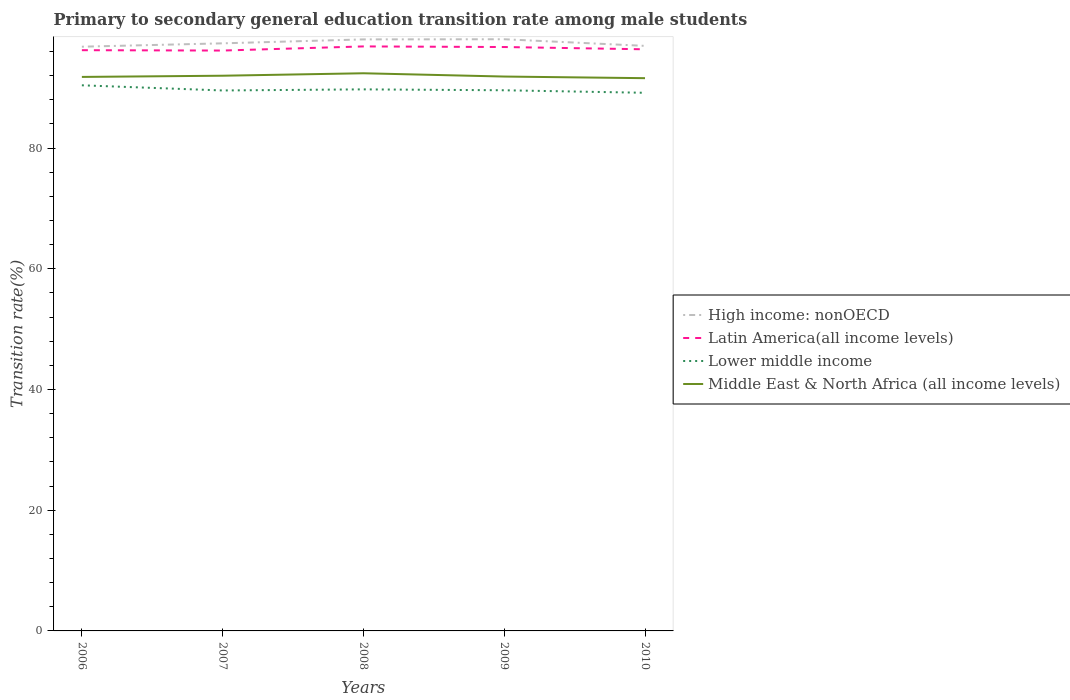Does the line corresponding to Lower middle income intersect with the line corresponding to High income: nonOECD?
Provide a succinct answer. No. Across all years, what is the maximum transition rate in Lower middle income?
Offer a terse response. 89.15. What is the total transition rate in Lower middle income in the graph?
Make the answer very short. 0.57. What is the difference between the highest and the second highest transition rate in High income: nonOECD?
Offer a very short reply. 1.23. What is the difference between the highest and the lowest transition rate in Middle East & North Africa (all income levels)?
Offer a terse response. 2. How many years are there in the graph?
Ensure brevity in your answer.  5. What is the difference between two consecutive major ticks on the Y-axis?
Make the answer very short. 20. Does the graph contain any zero values?
Offer a very short reply. No. Does the graph contain grids?
Offer a terse response. No. How many legend labels are there?
Your response must be concise. 4. What is the title of the graph?
Your answer should be very brief. Primary to secondary general education transition rate among male students. What is the label or title of the X-axis?
Ensure brevity in your answer.  Years. What is the label or title of the Y-axis?
Make the answer very short. Transition rate(%). What is the Transition rate(%) in High income: nonOECD in 2006?
Provide a short and direct response. 96.79. What is the Transition rate(%) in Latin America(all income levels) in 2006?
Provide a short and direct response. 96.21. What is the Transition rate(%) in Lower middle income in 2006?
Your answer should be very brief. 90.39. What is the Transition rate(%) of Middle East & North Africa (all income levels) in 2006?
Keep it short and to the point. 91.78. What is the Transition rate(%) of High income: nonOECD in 2007?
Offer a terse response. 97.34. What is the Transition rate(%) of Latin America(all income levels) in 2007?
Offer a very short reply. 96.15. What is the Transition rate(%) of Lower middle income in 2007?
Your answer should be compact. 89.54. What is the Transition rate(%) of Middle East & North Africa (all income levels) in 2007?
Your response must be concise. 91.98. What is the Transition rate(%) in High income: nonOECD in 2008?
Offer a very short reply. 98. What is the Transition rate(%) of Latin America(all income levels) in 2008?
Make the answer very short. 96.83. What is the Transition rate(%) of Lower middle income in 2008?
Ensure brevity in your answer.  89.72. What is the Transition rate(%) of Middle East & North Africa (all income levels) in 2008?
Make the answer very short. 92.38. What is the Transition rate(%) in High income: nonOECD in 2009?
Ensure brevity in your answer.  98.02. What is the Transition rate(%) of Latin America(all income levels) in 2009?
Offer a very short reply. 96.73. What is the Transition rate(%) in Lower middle income in 2009?
Offer a very short reply. 89.57. What is the Transition rate(%) of Middle East & North Africa (all income levels) in 2009?
Ensure brevity in your answer.  91.84. What is the Transition rate(%) of High income: nonOECD in 2010?
Give a very brief answer. 96.92. What is the Transition rate(%) in Latin America(all income levels) in 2010?
Your response must be concise. 96.36. What is the Transition rate(%) of Lower middle income in 2010?
Provide a succinct answer. 89.15. What is the Transition rate(%) in Middle East & North Africa (all income levels) in 2010?
Offer a terse response. 91.57. Across all years, what is the maximum Transition rate(%) of High income: nonOECD?
Your answer should be compact. 98.02. Across all years, what is the maximum Transition rate(%) in Latin America(all income levels)?
Your answer should be very brief. 96.83. Across all years, what is the maximum Transition rate(%) in Lower middle income?
Provide a short and direct response. 90.39. Across all years, what is the maximum Transition rate(%) in Middle East & North Africa (all income levels)?
Provide a succinct answer. 92.38. Across all years, what is the minimum Transition rate(%) in High income: nonOECD?
Keep it short and to the point. 96.79. Across all years, what is the minimum Transition rate(%) in Latin America(all income levels)?
Your answer should be very brief. 96.15. Across all years, what is the minimum Transition rate(%) in Lower middle income?
Keep it short and to the point. 89.15. Across all years, what is the minimum Transition rate(%) of Middle East & North Africa (all income levels)?
Give a very brief answer. 91.57. What is the total Transition rate(%) of High income: nonOECD in the graph?
Ensure brevity in your answer.  487.07. What is the total Transition rate(%) of Latin America(all income levels) in the graph?
Provide a succinct answer. 482.28. What is the total Transition rate(%) of Lower middle income in the graph?
Your answer should be very brief. 448.36. What is the total Transition rate(%) of Middle East & North Africa (all income levels) in the graph?
Provide a succinct answer. 459.56. What is the difference between the Transition rate(%) in High income: nonOECD in 2006 and that in 2007?
Give a very brief answer. -0.56. What is the difference between the Transition rate(%) of Latin America(all income levels) in 2006 and that in 2007?
Provide a short and direct response. 0.06. What is the difference between the Transition rate(%) of Lower middle income in 2006 and that in 2007?
Offer a terse response. 0.86. What is the difference between the Transition rate(%) of Middle East & North Africa (all income levels) in 2006 and that in 2007?
Provide a succinct answer. -0.2. What is the difference between the Transition rate(%) of High income: nonOECD in 2006 and that in 2008?
Your answer should be compact. -1.21. What is the difference between the Transition rate(%) in Latin America(all income levels) in 2006 and that in 2008?
Keep it short and to the point. -0.63. What is the difference between the Transition rate(%) of Lower middle income in 2006 and that in 2008?
Keep it short and to the point. 0.67. What is the difference between the Transition rate(%) of Middle East & North Africa (all income levels) in 2006 and that in 2008?
Your response must be concise. -0.6. What is the difference between the Transition rate(%) of High income: nonOECD in 2006 and that in 2009?
Offer a terse response. -1.23. What is the difference between the Transition rate(%) in Latin America(all income levels) in 2006 and that in 2009?
Your answer should be compact. -0.52. What is the difference between the Transition rate(%) of Lower middle income in 2006 and that in 2009?
Keep it short and to the point. 0.82. What is the difference between the Transition rate(%) of Middle East & North Africa (all income levels) in 2006 and that in 2009?
Offer a terse response. -0.06. What is the difference between the Transition rate(%) of High income: nonOECD in 2006 and that in 2010?
Make the answer very short. -0.14. What is the difference between the Transition rate(%) of Latin America(all income levels) in 2006 and that in 2010?
Your answer should be compact. -0.15. What is the difference between the Transition rate(%) of Lower middle income in 2006 and that in 2010?
Your response must be concise. 1.24. What is the difference between the Transition rate(%) in Middle East & North Africa (all income levels) in 2006 and that in 2010?
Offer a terse response. 0.21. What is the difference between the Transition rate(%) of High income: nonOECD in 2007 and that in 2008?
Offer a terse response. -0.65. What is the difference between the Transition rate(%) of Latin America(all income levels) in 2007 and that in 2008?
Give a very brief answer. -0.69. What is the difference between the Transition rate(%) in Lower middle income in 2007 and that in 2008?
Ensure brevity in your answer.  -0.18. What is the difference between the Transition rate(%) in Middle East & North Africa (all income levels) in 2007 and that in 2008?
Provide a succinct answer. -0.4. What is the difference between the Transition rate(%) in High income: nonOECD in 2007 and that in 2009?
Your answer should be very brief. -0.68. What is the difference between the Transition rate(%) in Latin America(all income levels) in 2007 and that in 2009?
Provide a short and direct response. -0.58. What is the difference between the Transition rate(%) in Lower middle income in 2007 and that in 2009?
Ensure brevity in your answer.  -0.03. What is the difference between the Transition rate(%) of Middle East & North Africa (all income levels) in 2007 and that in 2009?
Give a very brief answer. 0.14. What is the difference between the Transition rate(%) in High income: nonOECD in 2007 and that in 2010?
Give a very brief answer. 0.42. What is the difference between the Transition rate(%) of Latin America(all income levels) in 2007 and that in 2010?
Keep it short and to the point. -0.21. What is the difference between the Transition rate(%) in Lower middle income in 2007 and that in 2010?
Keep it short and to the point. 0.38. What is the difference between the Transition rate(%) of Middle East & North Africa (all income levels) in 2007 and that in 2010?
Give a very brief answer. 0.41. What is the difference between the Transition rate(%) in High income: nonOECD in 2008 and that in 2009?
Give a very brief answer. -0.02. What is the difference between the Transition rate(%) in Latin America(all income levels) in 2008 and that in 2009?
Provide a succinct answer. 0.1. What is the difference between the Transition rate(%) in Lower middle income in 2008 and that in 2009?
Your response must be concise. 0.15. What is the difference between the Transition rate(%) of Middle East & North Africa (all income levels) in 2008 and that in 2009?
Make the answer very short. 0.54. What is the difference between the Transition rate(%) in High income: nonOECD in 2008 and that in 2010?
Offer a terse response. 1.07. What is the difference between the Transition rate(%) in Latin America(all income levels) in 2008 and that in 2010?
Your response must be concise. 0.48. What is the difference between the Transition rate(%) in Lower middle income in 2008 and that in 2010?
Your answer should be compact. 0.57. What is the difference between the Transition rate(%) in Middle East & North Africa (all income levels) in 2008 and that in 2010?
Make the answer very short. 0.81. What is the difference between the Transition rate(%) of High income: nonOECD in 2009 and that in 2010?
Your answer should be compact. 1.1. What is the difference between the Transition rate(%) in Latin America(all income levels) in 2009 and that in 2010?
Offer a very short reply. 0.38. What is the difference between the Transition rate(%) in Lower middle income in 2009 and that in 2010?
Ensure brevity in your answer.  0.42. What is the difference between the Transition rate(%) of Middle East & North Africa (all income levels) in 2009 and that in 2010?
Provide a succinct answer. 0.27. What is the difference between the Transition rate(%) in High income: nonOECD in 2006 and the Transition rate(%) in Latin America(all income levels) in 2007?
Provide a succinct answer. 0.64. What is the difference between the Transition rate(%) of High income: nonOECD in 2006 and the Transition rate(%) of Lower middle income in 2007?
Provide a succinct answer. 7.25. What is the difference between the Transition rate(%) of High income: nonOECD in 2006 and the Transition rate(%) of Middle East & North Africa (all income levels) in 2007?
Offer a terse response. 4.81. What is the difference between the Transition rate(%) of Latin America(all income levels) in 2006 and the Transition rate(%) of Lower middle income in 2007?
Provide a short and direct response. 6.67. What is the difference between the Transition rate(%) of Latin America(all income levels) in 2006 and the Transition rate(%) of Middle East & North Africa (all income levels) in 2007?
Your answer should be compact. 4.23. What is the difference between the Transition rate(%) of Lower middle income in 2006 and the Transition rate(%) of Middle East & North Africa (all income levels) in 2007?
Offer a terse response. -1.59. What is the difference between the Transition rate(%) of High income: nonOECD in 2006 and the Transition rate(%) of Latin America(all income levels) in 2008?
Offer a terse response. -0.05. What is the difference between the Transition rate(%) in High income: nonOECD in 2006 and the Transition rate(%) in Lower middle income in 2008?
Provide a short and direct response. 7.07. What is the difference between the Transition rate(%) in High income: nonOECD in 2006 and the Transition rate(%) in Middle East & North Africa (all income levels) in 2008?
Provide a succinct answer. 4.4. What is the difference between the Transition rate(%) in Latin America(all income levels) in 2006 and the Transition rate(%) in Lower middle income in 2008?
Offer a terse response. 6.49. What is the difference between the Transition rate(%) of Latin America(all income levels) in 2006 and the Transition rate(%) of Middle East & North Africa (all income levels) in 2008?
Keep it short and to the point. 3.82. What is the difference between the Transition rate(%) of Lower middle income in 2006 and the Transition rate(%) of Middle East & North Africa (all income levels) in 2008?
Give a very brief answer. -1.99. What is the difference between the Transition rate(%) of High income: nonOECD in 2006 and the Transition rate(%) of Latin America(all income levels) in 2009?
Provide a succinct answer. 0.05. What is the difference between the Transition rate(%) of High income: nonOECD in 2006 and the Transition rate(%) of Lower middle income in 2009?
Your answer should be compact. 7.22. What is the difference between the Transition rate(%) in High income: nonOECD in 2006 and the Transition rate(%) in Middle East & North Africa (all income levels) in 2009?
Provide a succinct answer. 4.94. What is the difference between the Transition rate(%) of Latin America(all income levels) in 2006 and the Transition rate(%) of Lower middle income in 2009?
Keep it short and to the point. 6.64. What is the difference between the Transition rate(%) of Latin America(all income levels) in 2006 and the Transition rate(%) of Middle East & North Africa (all income levels) in 2009?
Make the answer very short. 4.37. What is the difference between the Transition rate(%) of Lower middle income in 2006 and the Transition rate(%) of Middle East & North Africa (all income levels) in 2009?
Give a very brief answer. -1.45. What is the difference between the Transition rate(%) in High income: nonOECD in 2006 and the Transition rate(%) in Latin America(all income levels) in 2010?
Make the answer very short. 0.43. What is the difference between the Transition rate(%) of High income: nonOECD in 2006 and the Transition rate(%) of Lower middle income in 2010?
Offer a terse response. 7.63. What is the difference between the Transition rate(%) of High income: nonOECD in 2006 and the Transition rate(%) of Middle East & North Africa (all income levels) in 2010?
Provide a succinct answer. 5.21. What is the difference between the Transition rate(%) in Latin America(all income levels) in 2006 and the Transition rate(%) in Lower middle income in 2010?
Keep it short and to the point. 7.06. What is the difference between the Transition rate(%) of Latin America(all income levels) in 2006 and the Transition rate(%) of Middle East & North Africa (all income levels) in 2010?
Offer a terse response. 4.63. What is the difference between the Transition rate(%) in Lower middle income in 2006 and the Transition rate(%) in Middle East & North Africa (all income levels) in 2010?
Keep it short and to the point. -1.18. What is the difference between the Transition rate(%) in High income: nonOECD in 2007 and the Transition rate(%) in Latin America(all income levels) in 2008?
Give a very brief answer. 0.51. What is the difference between the Transition rate(%) of High income: nonOECD in 2007 and the Transition rate(%) of Lower middle income in 2008?
Your answer should be compact. 7.63. What is the difference between the Transition rate(%) of High income: nonOECD in 2007 and the Transition rate(%) of Middle East & North Africa (all income levels) in 2008?
Provide a succinct answer. 4.96. What is the difference between the Transition rate(%) of Latin America(all income levels) in 2007 and the Transition rate(%) of Lower middle income in 2008?
Keep it short and to the point. 6.43. What is the difference between the Transition rate(%) of Latin America(all income levels) in 2007 and the Transition rate(%) of Middle East & North Africa (all income levels) in 2008?
Keep it short and to the point. 3.76. What is the difference between the Transition rate(%) of Lower middle income in 2007 and the Transition rate(%) of Middle East & North Africa (all income levels) in 2008?
Provide a succinct answer. -2.85. What is the difference between the Transition rate(%) in High income: nonOECD in 2007 and the Transition rate(%) in Latin America(all income levels) in 2009?
Your answer should be compact. 0.61. What is the difference between the Transition rate(%) in High income: nonOECD in 2007 and the Transition rate(%) in Lower middle income in 2009?
Offer a very short reply. 7.78. What is the difference between the Transition rate(%) in High income: nonOECD in 2007 and the Transition rate(%) in Middle East & North Africa (all income levels) in 2009?
Make the answer very short. 5.5. What is the difference between the Transition rate(%) of Latin America(all income levels) in 2007 and the Transition rate(%) of Lower middle income in 2009?
Provide a succinct answer. 6.58. What is the difference between the Transition rate(%) of Latin America(all income levels) in 2007 and the Transition rate(%) of Middle East & North Africa (all income levels) in 2009?
Provide a succinct answer. 4.31. What is the difference between the Transition rate(%) in Lower middle income in 2007 and the Transition rate(%) in Middle East & North Africa (all income levels) in 2009?
Provide a short and direct response. -2.31. What is the difference between the Transition rate(%) of High income: nonOECD in 2007 and the Transition rate(%) of Lower middle income in 2010?
Your answer should be compact. 8.19. What is the difference between the Transition rate(%) in High income: nonOECD in 2007 and the Transition rate(%) in Middle East & North Africa (all income levels) in 2010?
Your response must be concise. 5.77. What is the difference between the Transition rate(%) in Latin America(all income levels) in 2007 and the Transition rate(%) in Lower middle income in 2010?
Ensure brevity in your answer.  7. What is the difference between the Transition rate(%) in Latin America(all income levels) in 2007 and the Transition rate(%) in Middle East & North Africa (all income levels) in 2010?
Ensure brevity in your answer.  4.57. What is the difference between the Transition rate(%) of Lower middle income in 2007 and the Transition rate(%) of Middle East & North Africa (all income levels) in 2010?
Offer a very short reply. -2.04. What is the difference between the Transition rate(%) of High income: nonOECD in 2008 and the Transition rate(%) of Latin America(all income levels) in 2009?
Provide a short and direct response. 1.26. What is the difference between the Transition rate(%) of High income: nonOECD in 2008 and the Transition rate(%) of Lower middle income in 2009?
Provide a succinct answer. 8.43. What is the difference between the Transition rate(%) in High income: nonOECD in 2008 and the Transition rate(%) in Middle East & North Africa (all income levels) in 2009?
Give a very brief answer. 6.15. What is the difference between the Transition rate(%) in Latin America(all income levels) in 2008 and the Transition rate(%) in Lower middle income in 2009?
Your answer should be compact. 7.26. What is the difference between the Transition rate(%) of Latin America(all income levels) in 2008 and the Transition rate(%) of Middle East & North Africa (all income levels) in 2009?
Your response must be concise. 4.99. What is the difference between the Transition rate(%) of Lower middle income in 2008 and the Transition rate(%) of Middle East & North Africa (all income levels) in 2009?
Your response must be concise. -2.13. What is the difference between the Transition rate(%) in High income: nonOECD in 2008 and the Transition rate(%) in Latin America(all income levels) in 2010?
Your response must be concise. 1.64. What is the difference between the Transition rate(%) in High income: nonOECD in 2008 and the Transition rate(%) in Lower middle income in 2010?
Ensure brevity in your answer.  8.84. What is the difference between the Transition rate(%) of High income: nonOECD in 2008 and the Transition rate(%) of Middle East & North Africa (all income levels) in 2010?
Ensure brevity in your answer.  6.42. What is the difference between the Transition rate(%) of Latin America(all income levels) in 2008 and the Transition rate(%) of Lower middle income in 2010?
Your answer should be very brief. 7.68. What is the difference between the Transition rate(%) of Latin America(all income levels) in 2008 and the Transition rate(%) of Middle East & North Africa (all income levels) in 2010?
Ensure brevity in your answer.  5.26. What is the difference between the Transition rate(%) in Lower middle income in 2008 and the Transition rate(%) in Middle East & North Africa (all income levels) in 2010?
Provide a succinct answer. -1.86. What is the difference between the Transition rate(%) of High income: nonOECD in 2009 and the Transition rate(%) of Latin America(all income levels) in 2010?
Offer a very short reply. 1.66. What is the difference between the Transition rate(%) in High income: nonOECD in 2009 and the Transition rate(%) in Lower middle income in 2010?
Provide a succinct answer. 8.87. What is the difference between the Transition rate(%) in High income: nonOECD in 2009 and the Transition rate(%) in Middle East & North Africa (all income levels) in 2010?
Offer a very short reply. 6.45. What is the difference between the Transition rate(%) of Latin America(all income levels) in 2009 and the Transition rate(%) of Lower middle income in 2010?
Provide a short and direct response. 7.58. What is the difference between the Transition rate(%) of Latin America(all income levels) in 2009 and the Transition rate(%) of Middle East & North Africa (all income levels) in 2010?
Offer a very short reply. 5.16. What is the difference between the Transition rate(%) of Lower middle income in 2009 and the Transition rate(%) of Middle East & North Africa (all income levels) in 2010?
Your answer should be very brief. -2. What is the average Transition rate(%) of High income: nonOECD per year?
Your answer should be compact. 97.41. What is the average Transition rate(%) in Latin America(all income levels) per year?
Ensure brevity in your answer.  96.46. What is the average Transition rate(%) in Lower middle income per year?
Make the answer very short. 89.67. What is the average Transition rate(%) of Middle East & North Africa (all income levels) per year?
Provide a short and direct response. 91.91. In the year 2006, what is the difference between the Transition rate(%) in High income: nonOECD and Transition rate(%) in Latin America(all income levels)?
Offer a very short reply. 0.58. In the year 2006, what is the difference between the Transition rate(%) in High income: nonOECD and Transition rate(%) in Lower middle income?
Your answer should be compact. 6.4. In the year 2006, what is the difference between the Transition rate(%) in High income: nonOECD and Transition rate(%) in Middle East & North Africa (all income levels)?
Provide a succinct answer. 5.01. In the year 2006, what is the difference between the Transition rate(%) of Latin America(all income levels) and Transition rate(%) of Lower middle income?
Your answer should be compact. 5.82. In the year 2006, what is the difference between the Transition rate(%) of Latin America(all income levels) and Transition rate(%) of Middle East & North Africa (all income levels)?
Keep it short and to the point. 4.43. In the year 2006, what is the difference between the Transition rate(%) in Lower middle income and Transition rate(%) in Middle East & North Africa (all income levels)?
Your answer should be compact. -1.39. In the year 2007, what is the difference between the Transition rate(%) in High income: nonOECD and Transition rate(%) in Latin America(all income levels)?
Keep it short and to the point. 1.2. In the year 2007, what is the difference between the Transition rate(%) of High income: nonOECD and Transition rate(%) of Lower middle income?
Your answer should be very brief. 7.81. In the year 2007, what is the difference between the Transition rate(%) of High income: nonOECD and Transition rate(%) of Middle East & North Africa (all income levels)?
Offer a terse response. 5.36. In the year 2007, what is the difference between the Transition rate(%) in Latin America(all income levels) and Transition rate(%) in Lower middle income?
Make the answer very short. 6.61. In the year 2007, what is the difference between the Transition rate(%) in Latin America(all income levels) and Transition rate(%) in Middle East & North Africa (all income levels)?
Offer a terse response. 4.17. In the year 2007, what is the difference between the Transition rate(%) of Lower middle income and Transition rate(%) of Middle East & North Africa (all income levels)?
Your response must be concise. -2.44. In the year 2008, what is the difference between the Transition rate(%) in High income: nonOECD and Transition rate(%) in Latin America(all income levels)?
Ensure brevity in your answer.  1.16. In the year 2008, what is the difference between the Transition rate(%) of High income: nonOECD and Transition rate(%) of Lower middle income?
Give a very brief answer. 8.28. In the year 2008, what is the difference between the Transition rate(%) of High income: nonOECD and Transition rate(%) of Middle East & North Africa (all income levels)?
Provide a succinct answer. 5.61. In the year 2008, what is the difference between the Transition rate(%) in Latin America(all income levels) and Transition rate(%) in Lower middle income?
Make the answer very short. 7.12. In the year 2008, what is the difference between the Transition rate(%) in Latin America(all income levels) and Transition rate(%) in Middle East & North Africa (all income levels)?
Your response must be concise. 4.45. In the year 2008, what is the difference between the Transition rate(%) in Lower middle income and Transition rate(%) in Middle East & North Africa (all income levels)?
Offer a terse response. -2.67. In the year 2009, what is the difference between the Transition rate(%) in High income: nonOECD and Transition rate(%) in Latin America(all income levels)?
Offer a very short reply. 1.29. In the year 2009, what is the difference between the Transition rate(%) in High income: nonOECD and Transition rate(%) in Lower middle income?
Keep it short and to the point. 8.45. In the year 2009, what is the difference between the Transition rate(%) in High income: nonOECD and Transition rate(%) in Middle East & North Africa (all income levels)?
Provide a succinct answer. 6.18. In the year 2009, what is the difference between the Transition rate(%) in Latin America(all income levels) and Transition rate(%) in Lower middle income?
Give a very brief answer. 7.16. In the year 2009, what is the difference between the Transition rate(%) of Latin America(all income levels) and Transition rate(%) of Middle East & North Africa (all income levels)?
Ensure brevity in your answer.  4.89. In the year 2009, what is the difference between the Transition rate(%) of Lower middle income and Transition rate(%) of Middle East & North Africa (all income levels)?
Give a very brief answer. -2.27. In the year 2010, what is the difference between the Transition rate(%) in High income: nonOECD and Transition rate(%) in Latin America(all income levels)?
Make the answer very short. 0.57. In the year 2010, what is the difference between the Transition rate(%) in High income: nonOECD and Transition rate(%) in Lower middle income?
Give a very brief answer. 7.77. In the year 2010, what is the difference between the Transition rate(%) in High income: nonOECD and Transition rate(%) in Middle East & North Africa (all income levels)?
Make the answer very short. 5.35. In the year 2010, what is the difference between the Transition rate(%) of Latin America(all income levels) and Transition rate(%) of Lower middle income?
Offer a very short reply. 7.2. In the year 2010, what is the difference between the Transition rate(%) in Latin America(all income levels) and Transition rate(%) in Middle East & North Africa (all income levels)?
Your answer should be compact. 4.78. In the year 2010, what is the difference between the Transition rate(%) in Lower middle income and Transition rate(%) in Middle East & North Africa (all income levels)?
Offer a very short reply. -2.42. What is the ratio of the Transition rate(%) of High income: nonOECD in 2006 to that in 2007?
Keep it short and to the point. 0.99. What is the ratio of the Transition rate(%) of Latin America(all income levels) in 2006 to that in 2007?
Your response must be concise. 1. What is the ratio of the Transition rate(%) of Lower middle income in 2006 to that in 2007?
Offer a very short reply. 1.01. What is the ratio of the Transition rate(%) of Middle East & North Africa (all income levels) in 2006 to that in 2007?
Your response must be concise. 1. What is the ratio of the Transition rate(%) in High income: nonOECD in 2006 to that in 2008?
Your answer should be compact. 0.99. What is the ratio of the Transition rate(%) of Latin America(all income levels) in 2006 to that in 2008?
Your answer should be compact. 0.99. What is the ratio of the Transition rate(%) in Lower middle income in 2006 to that in 2008?
Give a very brief answer. 1.01. What is the ratio of the Transition rate(%) in High income: nonOECD in 2006 to that in 2009?
Your answer should be compact. 0.99. What is the ratio of the Transition rate(%) in Latin America(all income levels) in 2006 to that in 2009?
Provide a short and direct response. 0.99. What is the ratio of the Transition rate(%) of Lower middle income in 2006 to that in 2009?
Offer a terse response. 1.01. What is the ratio of the Transition rate(%) in Middle East & North Africa (all income levels) in 2006 to that in 2009?
Offer a very short reply. 1. What is the ratio of the Transition rate(%) of Latin America(all income levels) in 2006 to that in 2010?
Your answer should be compact. 1. What is the ratio of the Transition rate(%) in Lower middle income in 2006 to that in 2010?
Keep it short and to the point. 1.01. What is the ratio of the Transition rate(%) in Middle East & North Africa (all income levels) in 2006 to that in 2010?
Offer a terse response. 1. What is the ratio of the Transition rate(%) in Latin America(all income levels) in 2007 to that in 2008?
Provide a succinct answer. 0.99. What is the ratio of the Transition rate(%) in Lower middle income in 2007 to that in 2008?
Give a very brief answer. 1. What is the ratio of the Transition rate(%) of Middle East & North Africa (all income levels) in 2007 to that in 2008?
Give a very brief answer. 1. What is the ratio of the Transition rate(%) in High income: nonOECD in 2007 to that in 2009?
Offer a very short reply. 0.99. What is the ratio of the Transition rate(%) of Latin America(all income levels) in 2007 to that in 2009?
Offer a terse response. 0.99. What is the ratio of the Transition rate(%) in Middle East & North Africa (all income levels) in 2007 to that in 2009?
Your answer should be compact. 1. What is the ratio of the Transition rate(%) of Middle East & North Africa (all income levels) in 2007 to that in 2010?
Your answer should be compact. 1. What is the ratio of the Transition rate(%) of Latin America(all income levels) in 2008 to that in 2009?
Your response must be concise. 1. What is the ratio of the Transition rate(%) in Middle East & North Africa (all income levels) in 2008 to that in 2009?
Your response must be concise. 1.01. What is the ratio of the Transition rate(%) of High income: nonOECD in 2008 to that in 2010?
Provide a succinct answer. 1.01. What is the ratio of the Transition rate(%) in Lower middle income in 2008 to that in 2010?
Your answer should be compact. 1.01. What is the ratio of the Transition rate(%) of Middle East & North Africa (all income levels) in 2008 to that in 2010?
Offer a very short reply. 1.01. What is the ratio of the Transition rate(%) of High income: nonOECD in 2009 to that in 2010?
Provide a succinct answer. 1.01. What is the ratio of the Transition rate(%) of Latin America(all income levels) in 2009 to that in 2010?
Offer a terse response. 1. What is the ratio of the Transition rate(%) of Middle East & North Africa (all income levels) in 2009 to that in 2010?
Ensure brevity in your answer.  1. What is the difference between the highest and the second highest Transition rate(%) in High income: nonOECD?
Offer a terse response. 0.02. What is the difference between the highest and the second highest Transition rate(%) in Latin America(all income levels)?
Ensure brevity in your answer.  0.1. What is the difference between the highest and the second highest Transition rate(%) of Lower middle income?
Provide a short and direct response. 0.67. What is the difference between the highest and the second highest Transition rate(%) of Middle East & North Africa (all income levels)?
Your answer should be compact. 0.4. What is the difference between the highest and the lowest Transition rate(%) in High income: nonOECD?
Your answer should be compact. 1.23. What is the difference between the highest and the lowest Transition rate(%) in Latin America(all income levels)?
Your answer should be very brief. 0.69. What is the difference between the highest and the lowest Transition rate(%) of Lower middle income?
Make the answer very short. 1.24. What is the difference between the highest and the lowest Transition rate(%) of Middle East & North Africa (all income levels)?
Offer a very short reply. 0.81. 